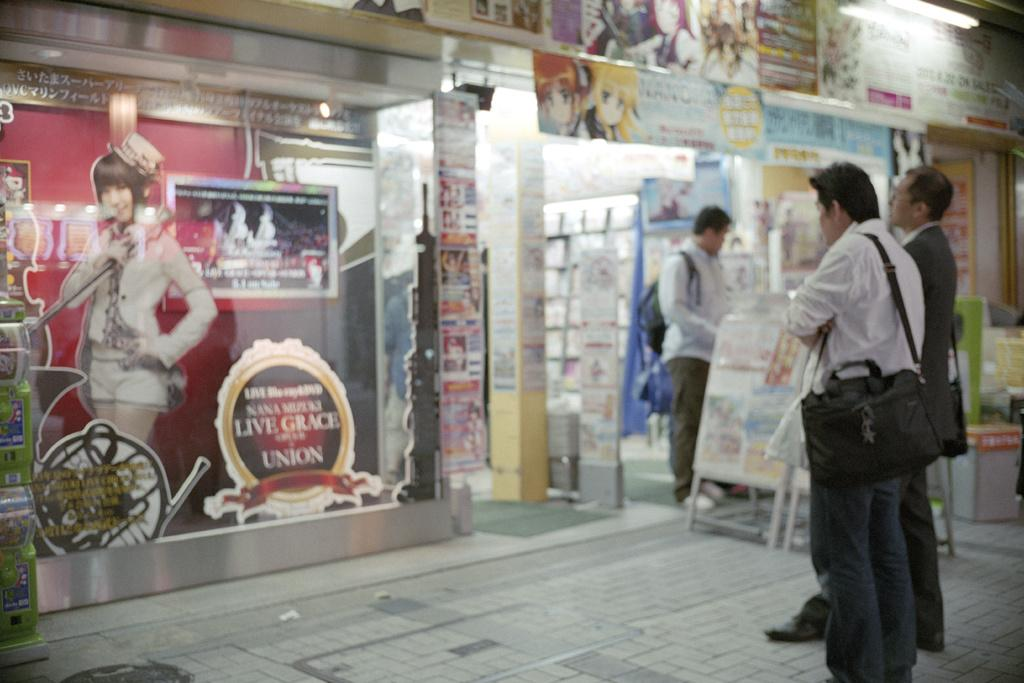<image>
Write a terse but informative summary of the picture. A sign with live grace upon it is in the window. 